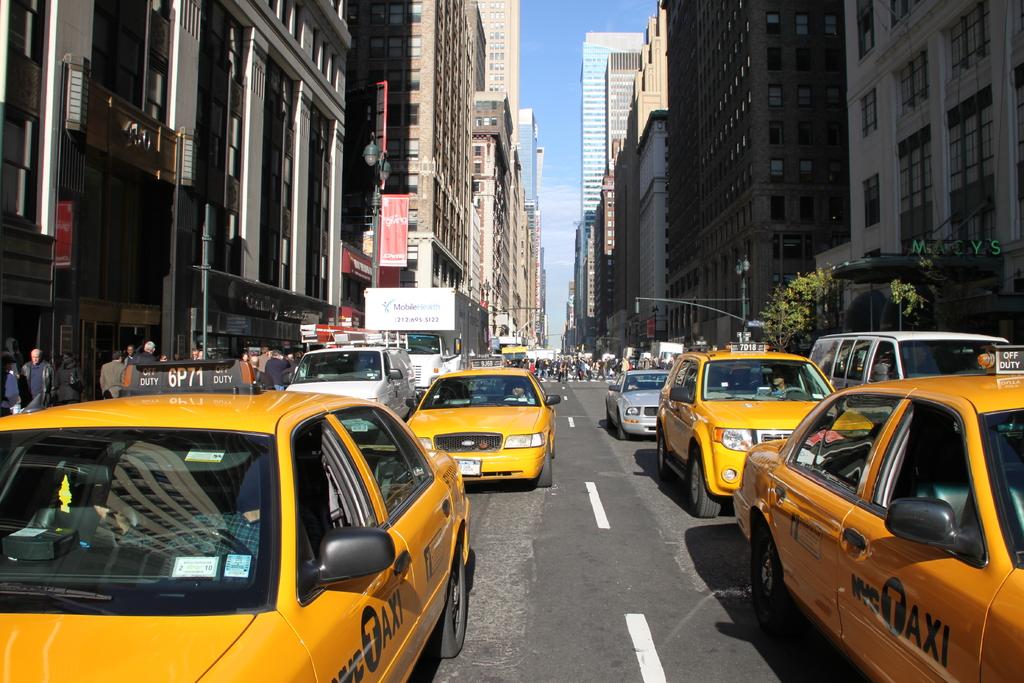What is on the side of the car?
Offer a very short reply. Taxi. What is the taxi number on the left taxi?
Your answer should be compact. 6p71. 